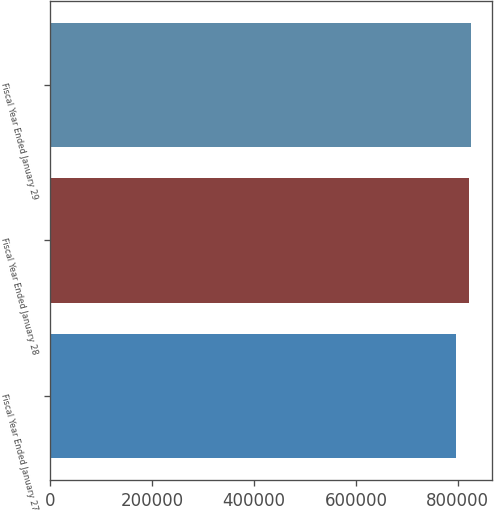Convert chart. <chart><loc_0><loc_0><loc_500><loc_500><bar_chart><fcel>Fiscal Year Ended January 27<fcel>Fiscal Year Ended January 28<fcel>Fiscal Year Ended January 29<nl><fcel>795860<fcel>822418<fcel>825255<nl></chart> 